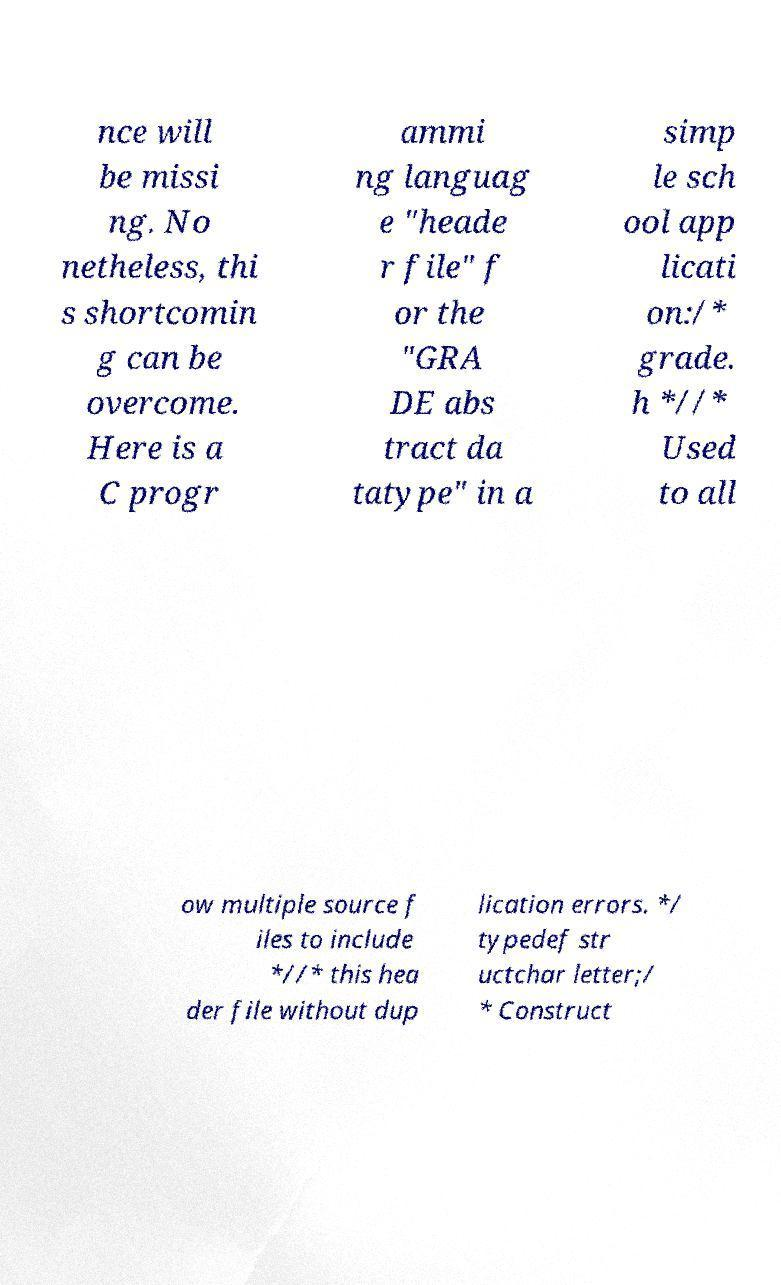For documentation purposes, I need the text within this image transcribed. Could you provide that? nce will be missi ng. No netheless, thi s shortcomin g can be overcome. Here is a C progr ammi ng languag e "heade r file" f or the "GRA DE abs tract da tatype" in a simp le sch ool app licati on:/* grade. h *//* Used to all ow multiple source f iles to include *//* this hea der file without dup lication errors. */ typedef str uctchar letter;/ * Construct 